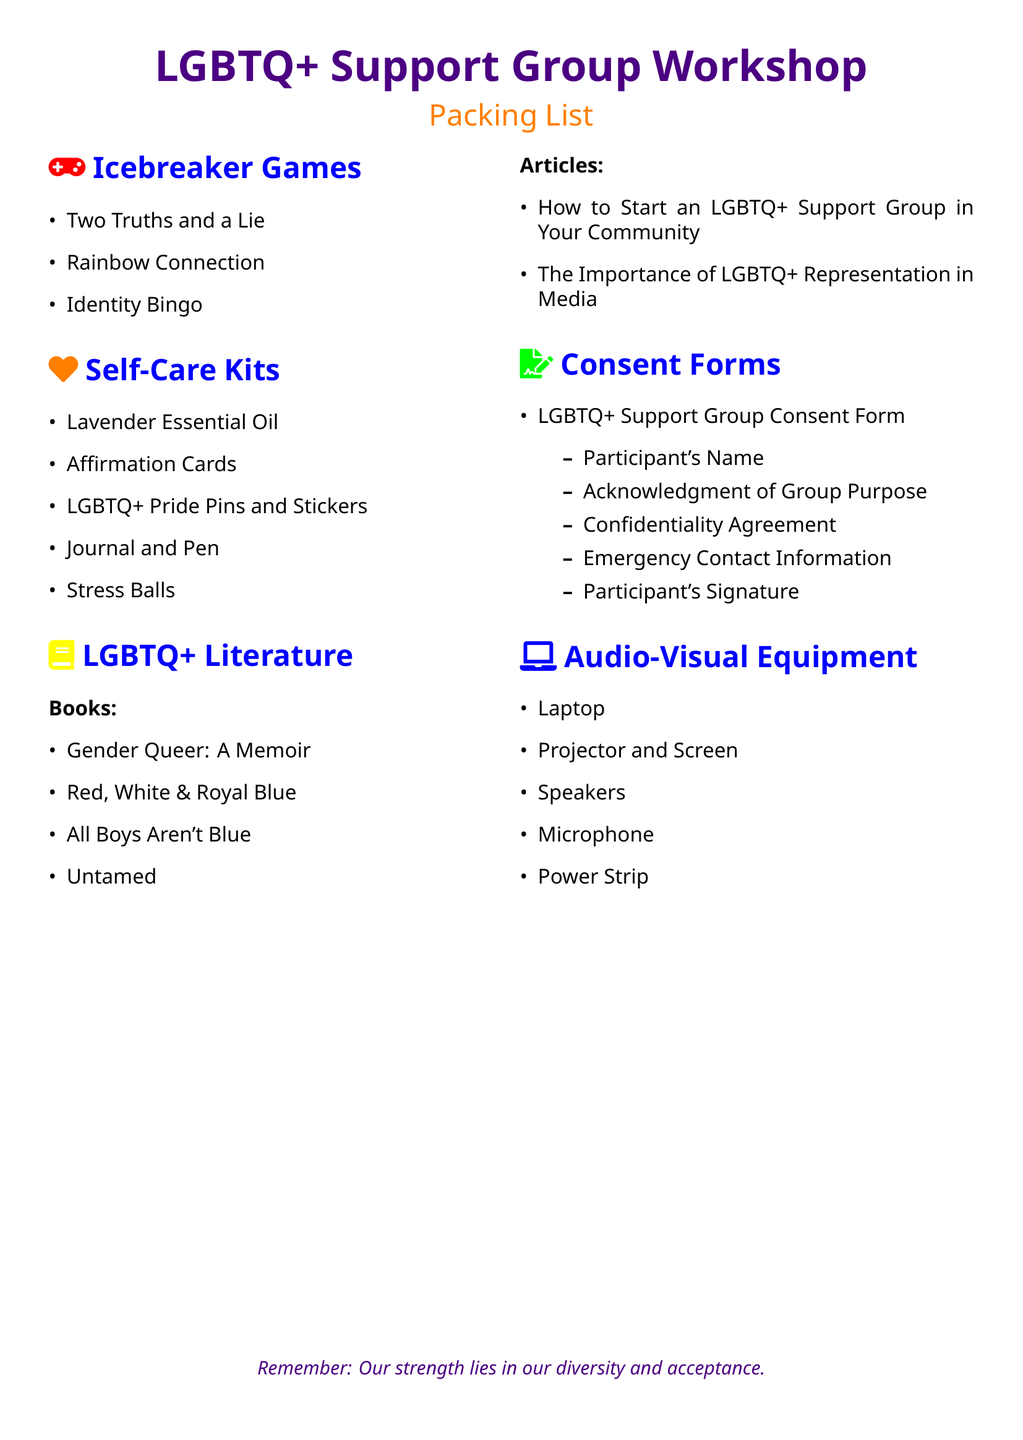What item is listed under Icebreaker Games? Icebreaker Games includes a list of activities to help participants get to know each other, one of which is "Two Truths and a Lie."
Answer: Two Truths and a Lie How many books are listed in the LGBTQ+ Literature section? The document contains a section on LGBTQ+ Literature that includes four specific titles under Books.
Answer: 4 What is one item found in the Self-Care Kits? The Self-Care Kits section features several items, including "Lavender Essential Oil."
Answer: Lavender Essential Oil What is the purpose of the Consent Form? The Consent Form is a document to acknowledge the group purpose and ensure participant agreement and confidentiality, which is detailed in the list.
Answer: Confidentiality Agreement What audio-visual equipment is required for the workshop? The Audio-Visual Equipment section lists essential items needed for the workshop, with "Laptop" being one of them.
Answer: Laptop Which article is included in the LGBTQ+ Literature section? Among the articles listed, "How to Start an LGBTQ+ Support Group in Your Community" is one of the titles.
Answer: How to Start an LGBTQ+ Support Group in Your Community What color represents the title of the workshop? The title color is specified in the document, which is "rainbowpurple."
Answer: rainbowpurple What type of self-care item is mentioned in the Self-Care Kits? One of the self-care items listed is "Stress Balls," which is intended for relaxation and coping.
Answer: Stress Balls 